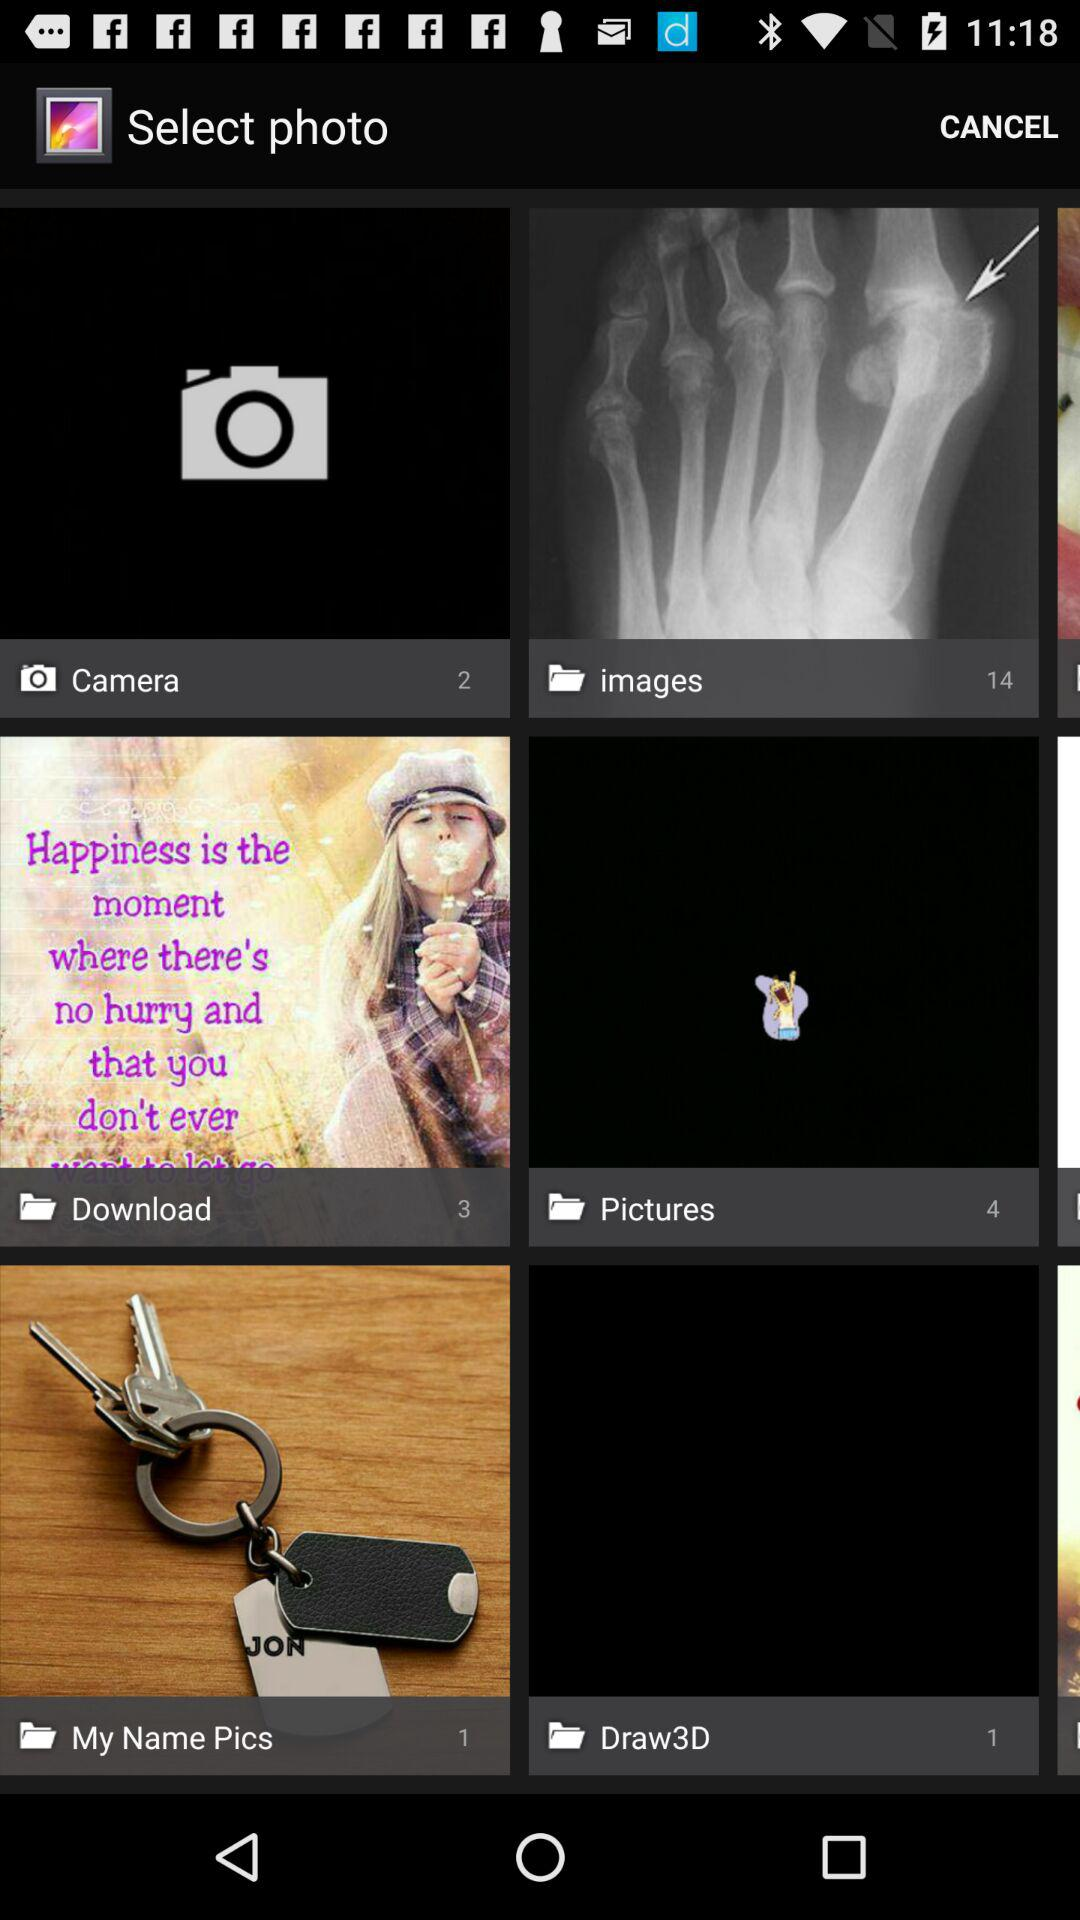How many pictures are there in the "My Name Pics" folder? There is 1 picture in the "My Name Pics" folder. 